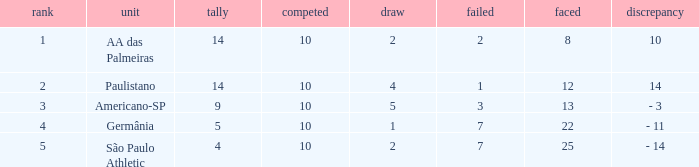Can you give me this table as a dict? {'header': ['rank', 'unit', 'tally', 'competed', 'draw', 'failed', 'faced', 'discrepancy'], 'rows': [['1', 'AA das Palmeiras', '14', '10', '2', '2', '8', '10'], ['2', 'Paulistano', '14', '10', '4', '1', '12', '14'], ['3', 'Americano-SP', '9', '10', '5', '3', '13', '- 3'], ['4', 'Germânia', '5', '10', '1', '7', '22', '- 11'], ['5', 'São Paulo Athletic', '4', '10', '2', '7', '25', '- 14']]} What is the lowest Against when the played is more than 10? None. 